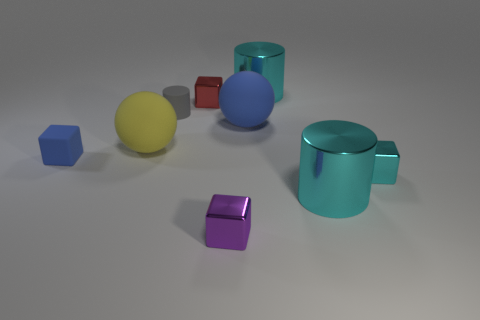What number of objects are either small blue matte things or blocks that are behind the yellow ball?
Offer a very short reply. 2. Are there any large shiny cylinders behind the yellow matte ball in front of the tiny gray rubber object?
Offer a terse response. Yes. What color is the large thing that is in front of the small cyan metal block?
Your response must be concise. Cyan. Are there an equal number of blue rubber cubes in front of the small cyan shiny cube and tiny purple cubes?
Your answer should be compact. No. What shape is the thing that is on the right side of the gray rubber thing and on the left side of the small purple cube?
Make the answer very short. Cube. What is the color of the other matte object that is the same shape as the red object?
Make the answer very short. Blue. Is there anything else of the same color as the tiny cylinder?
Make the answer very short. No. There is a large thing that is in front of the tiny cube on the right side of the big metallic object that is behind the red block; what is its shape?
Make the answer very short. Cylinder. Does the yellow rubber thing in front of the small red metal thing have the same size as the matte object that is right of the purple metallic cube?
Your response must be concise. Yes. What number of purple objects have the same material as the red object?
Make the answer very short. 1. 